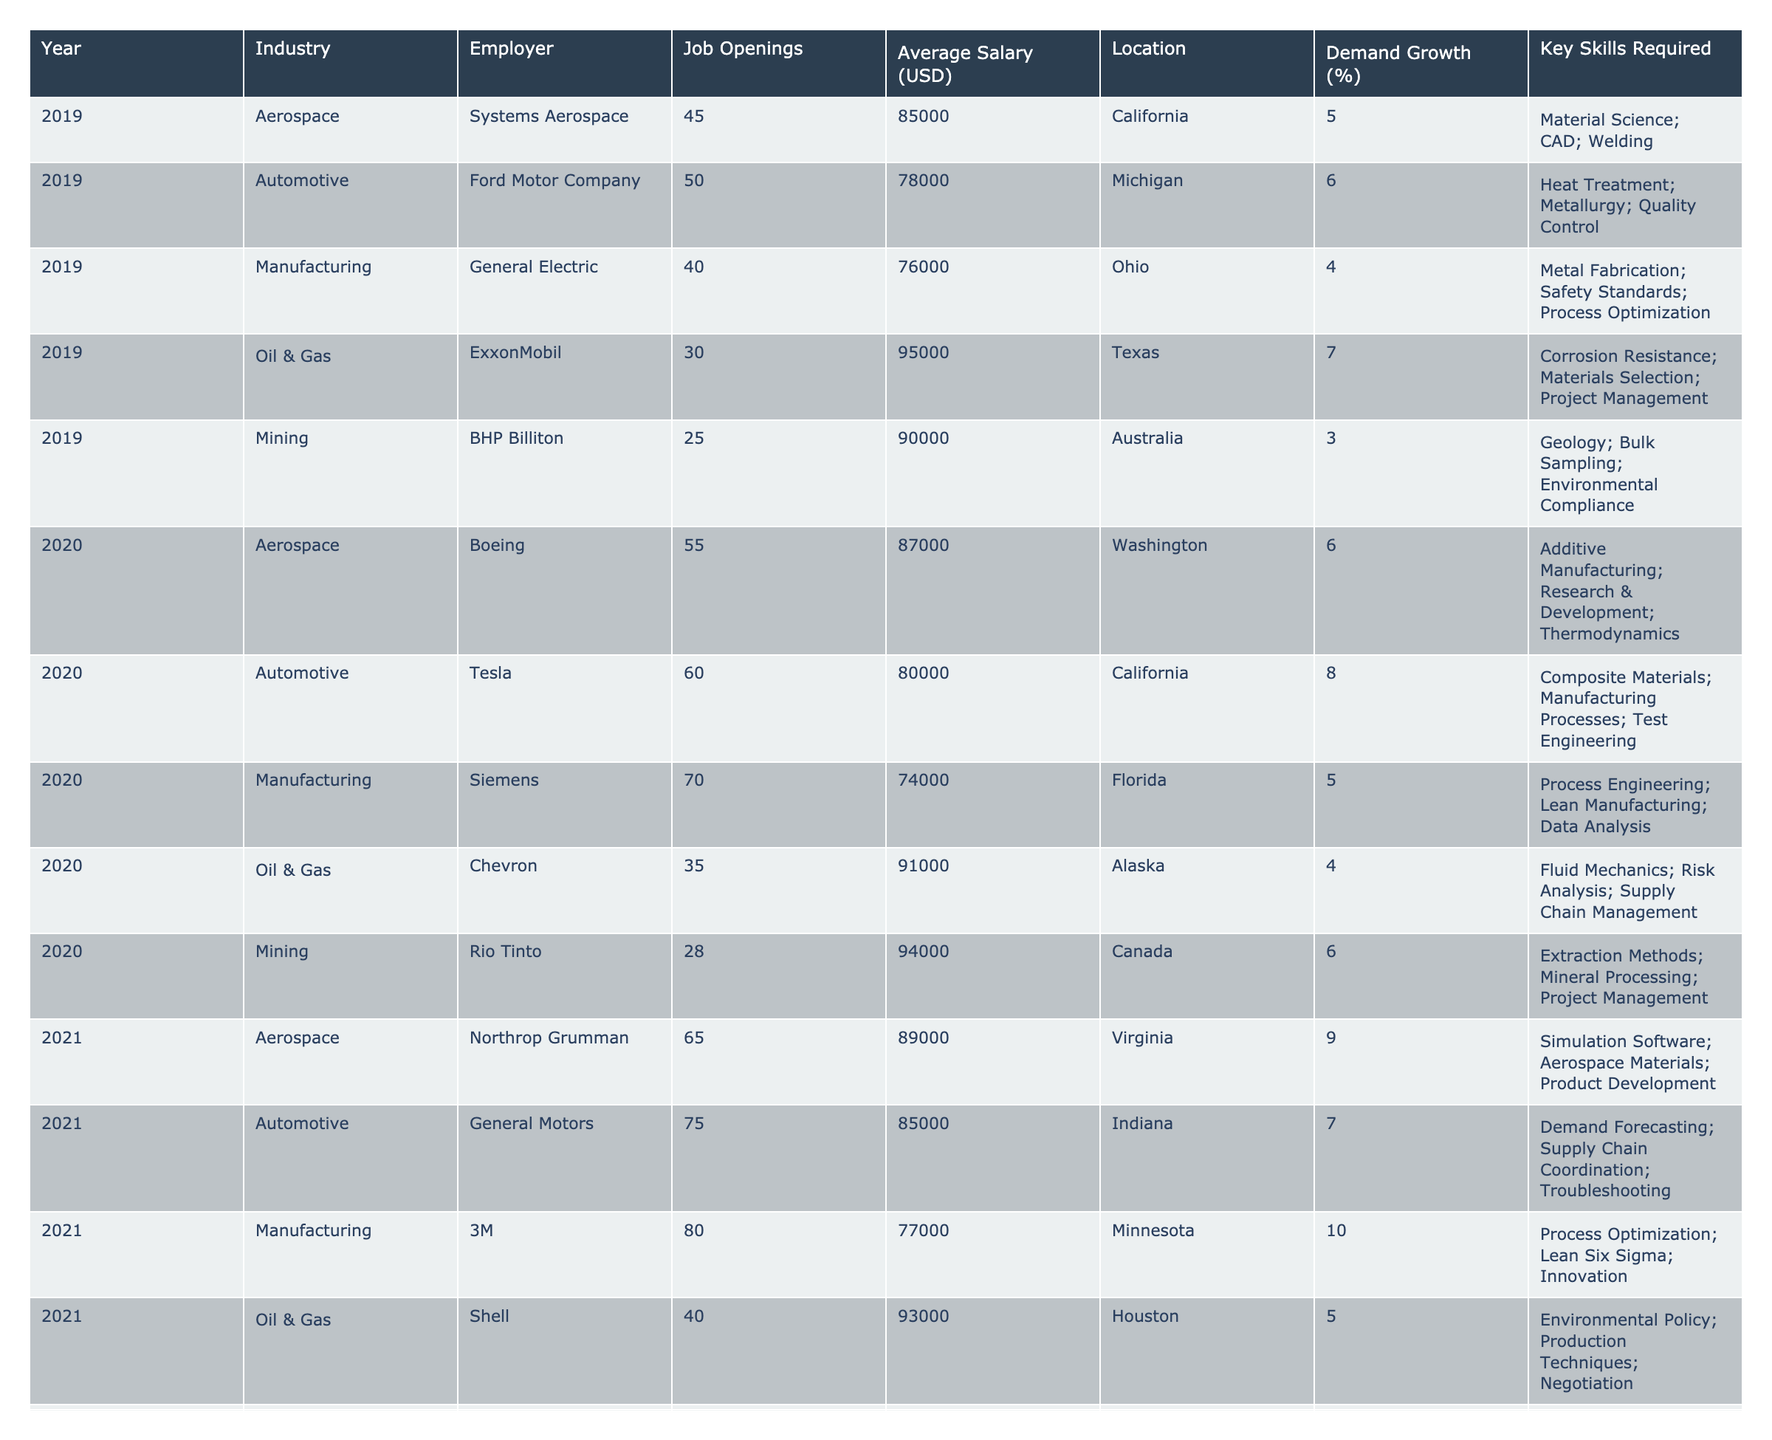What is the average salary for metallurgists in the Automotive industry in 2022? The salaries for the Automotive industry in 2022 can be found in the table: Honda ($83,000) and Volkswagen ($86,000). To find the average, we sum these salaries: ($83,000 + $86,000) = $169,000, and then divide by the number of employers (2): $169,000 / 2 = $84,500.
Answer: $84,500 Which industry had the highest job openings in 2023? In 2023, the job openings listed are: Aerospace (100), Automotive (85), Manufacturing (110), Oil & Gas (55), and Mining (40). The highest value is 110 for Manufacturing.
Answer: Manufacturing What percentage growth in demand for metallurgists was observed in the Aerospace industry from 2019 to 2023? The demand growth in 2019 was 5%, and in 2023 it is 12%. To find the percentage increase, calculate: (12 - 5) = 7%.
Answer: 7% Did the mining industry show an increase in average salary from 2019 to 2023? In 2019, the average salary for Mining was $90,000, and in 2023 it is $99,000. Since $99,000 > $90,000, it confirms that there was an increase.
Answer: Yes What is the total number of job openings across all industries in 2021? To find the total job openings in 2021, we sum the openings: 65 (Aerospace) + 75 (Automotive) + 80 (Manufacturing) + 40 (Oil & Gas) + 30 (Mining) = 290.
Answer: 290 Which state had the highest average salary for metallurgists in 2022? The average salaries in 2022 are as follows: Arizona ($91,000), Ohio ($83,000), California ($78,000), Louisiana ($97,000), and South Africa ($98,000). The highest salary is in South Africa at $98,000.
Answer: South Africa What is the demand growth percentage for the Oil & Gas industry in 2019? The demand growth percentage for Oil & Gas in 2019 is listed directly in the table as 7%.
Answer: 7% How does the average salary of metallurgists in the Manufacturing industry compare between 2019 and 2023? The average salary in 2019 was $76,000 and in 2023 it is $80,000. Comparing these shows an increase of $4,000 over the period.
Answer: Increased by $4,000 What are the key skills required for metallurgy positions in the Automotive industry in 2020? In 2020, the key skills required for the Automotive industry were Composite Materials, Manufacturing Processes, and Test Engineering, as listed in the table.
Answer: Composite Materials; Manufacturing Processes; Test Engineering Which year saw the highest demand growth for metallurgists in the Manufacturing industry? The demand growth percentages for Manufacturing across the years are: 4% (2019), 5% (2020), 10% (2021), 7% (2022), and 14% (2023). The highest figure is 14% in 2023.
Answer: 2023 